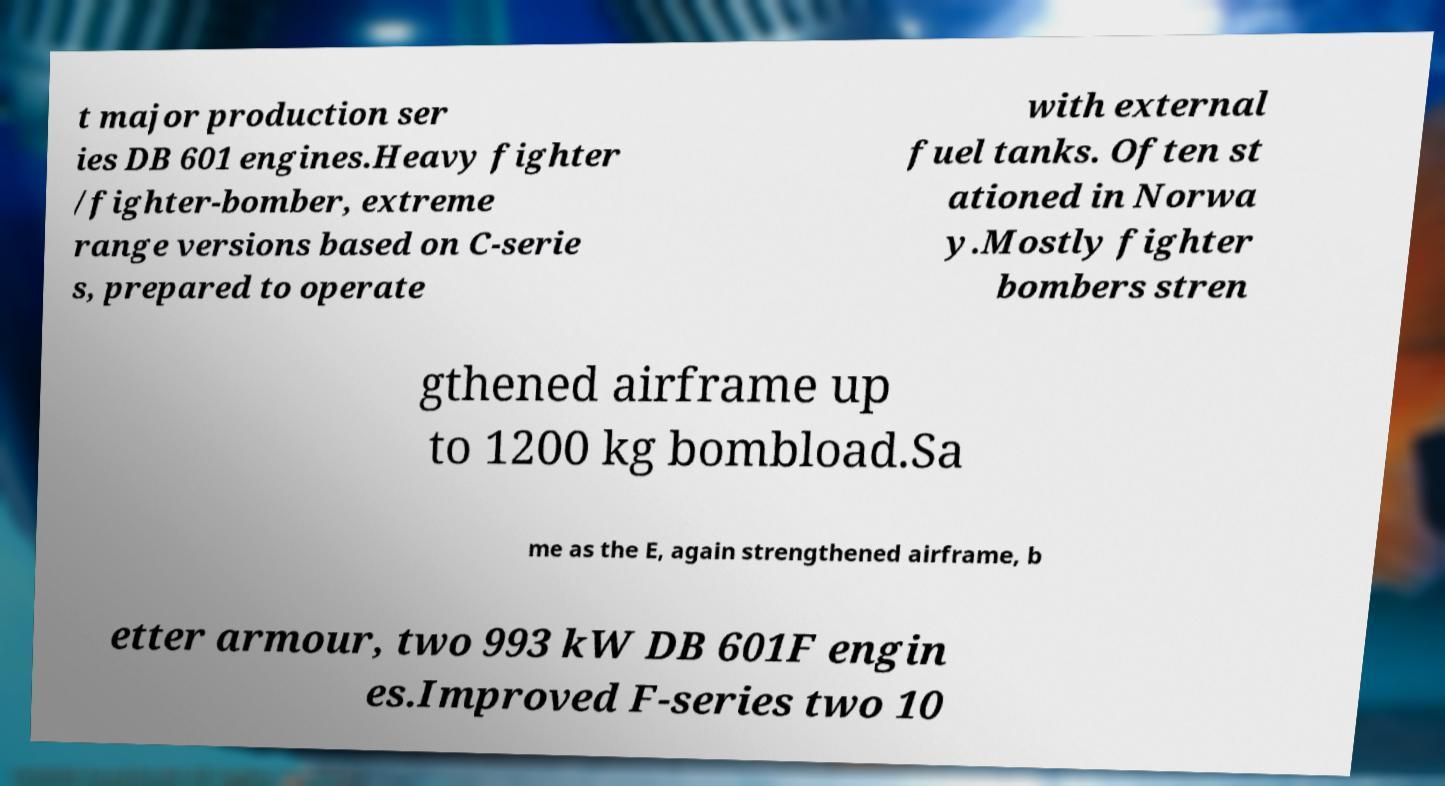Can you read and provide the text displayed in the image?This photo seems to have some interesting text. Can you extract and type it out for me? t major production ser ies DB 601 engines.Heavy fighter /fighter-bomber, extreme range versions based on C-serie s, prepared to operate with external fuel tanks. Often st ationed in Norwa y.Mostly fighter bombers stren gthened airframe up to 1200 kg bombload.Sa me as the E, again strengthened airframe, b etter armour, two 993 kW DB 601F engin es.Improved F-series two 10 